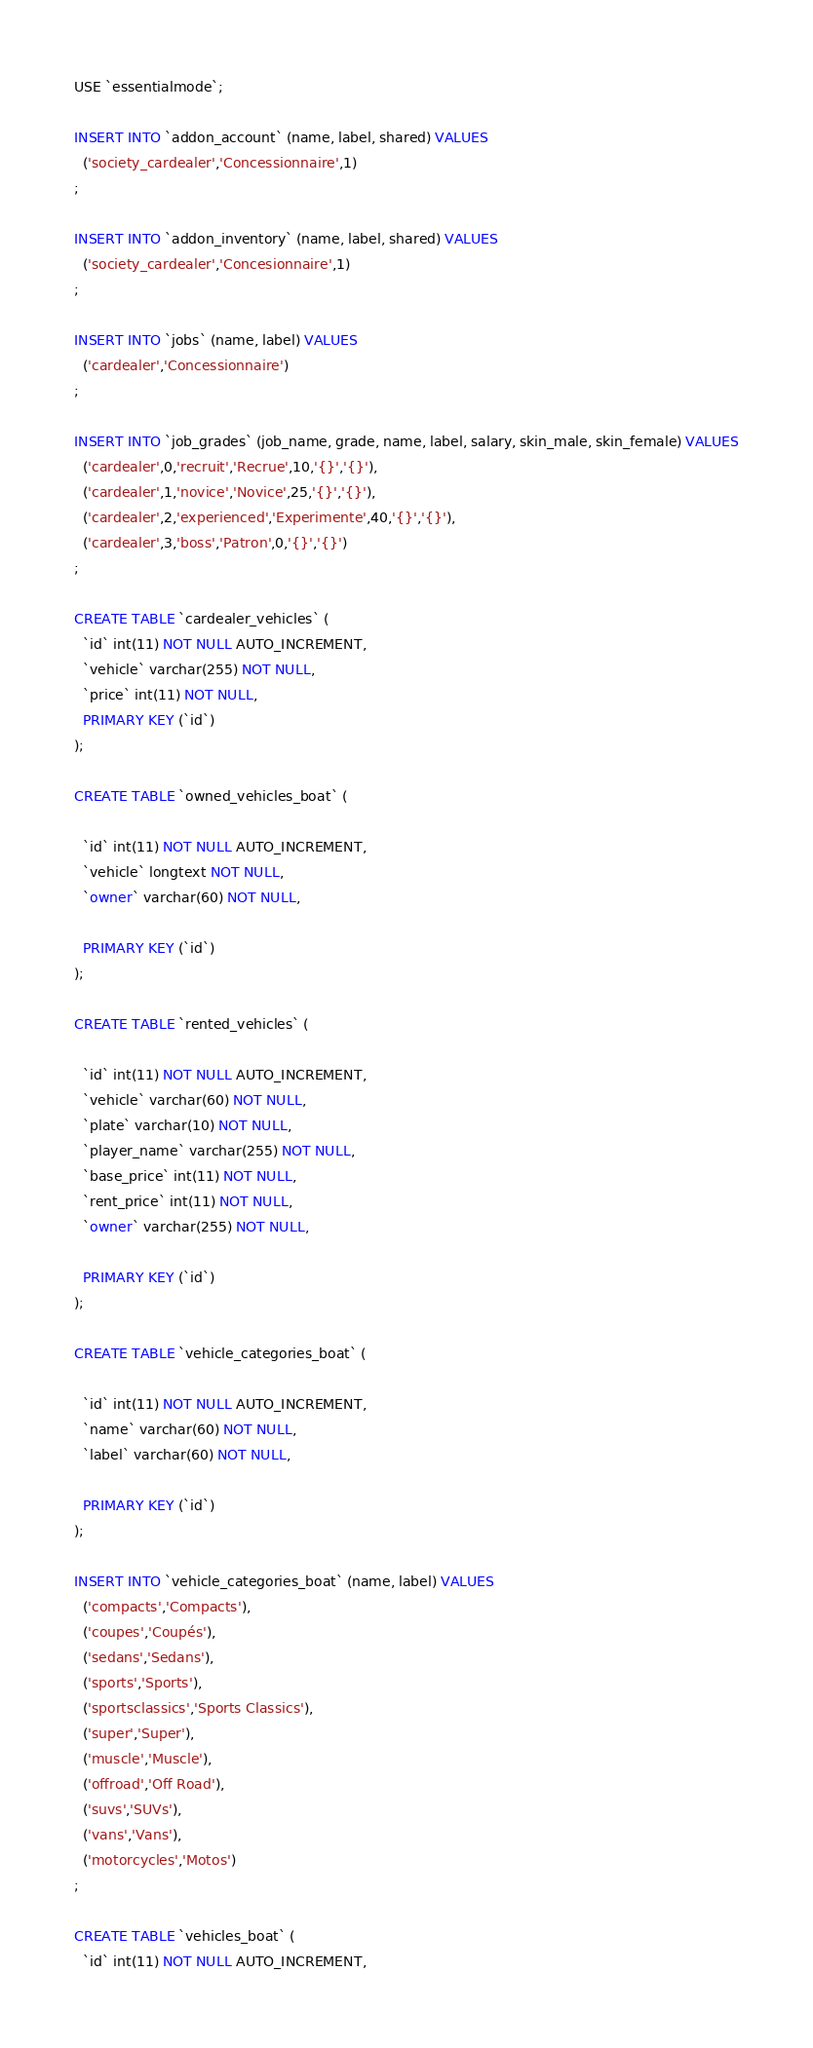<code> <loc_0><loc_0><loc_500><loc_500><_SQL_>USE `essentialmode`;

INSERT INTO `addon_account` (name, label, shared) VALUES
  ('society_cardealer','Concessionnaire',1)
;

INSERT INTO `addon_inventory` (name, label, shared) VALUES
  ('society_cardealer','Concesionnaire',1)
;

INSERT INTO `jobs` (name, label) VALUES
  ('cardealer','Concessionnaire')
;

INSERT INTO `job_grades` (job_name, grade, name, label, salary, skin_male, skin_female) VALUES
  ('cardealer',0,'recruit','Recrue',10,'{}','{}'),
  ('cardealer',1,'novice','Novice',25,'{}','{}'),
  ('cardealer',2,'experienced','Experimente',40,'{}','{}'),
  ('cardealer',3,'boss','Patron',0,'{}','{}')
;

CREATE TABLE `cardealer_vehicles` (
  `id` int(11) NOT NULL AUTO_INCREMENT,
  `vehicle` varchar(255) NOT NULL,
  `price` int(11) NOT NULL,
  PRIMARY KEY (`id`)
);

CREATE TABLE `owned_vehicles_boat` (

  `id` int(11) NOT NULL AUTO_INCREMENT,
  `vehicle` longtext NOT NULL,
  `owner` varchar(60) NOT NULL,

  PRIMARY KEY (`id`)
);

CREATE TABLE `rented_vehicles` (

  `id` int(11) NOT NULL AUTO_INCREMENT,
  `vehicle` varchar(60) NOT NULL,
  `plate` varchar(10) NOT NULL,
  `player_name` varchar(255) NOT NULL,
  `base_price` int(11) NOT NULL,
  `rent_price` int(11) NOT NULL,
  `owner` varchar(255) NOT NULL,

  PRIMARY KEY (`id`)
);

CREATE TABLE `vehicle_categories_boat` (

  `id` int(11) NOT NULL AUTO_INCREMENT,
  `name` varchar(60) NOT NULL,
  `label` varchar(60) NOT NULL,

  PRIMARY KEY (`id`)
);

INSERT INTO `vehicle_categories_boat` (name, label) VALUES
  ('compacts','Compacts'),
  ('coupes','Coupés'),
  ('sedans','Sedans'),
  ('sports','Sports'),
  ('sportsclassics','Sports Classics'),
  ('super','Super'),
  ('muscle','Muscle'),
  ('offroad','Off Road'),
  ('suvs','SUVs'),
  ('vans','Vans'),
  ('motorcycles','Motos')
;

CREATE TABLE `vehicles_boat` (
  `id` int(11) NOT NULL AUTO_INCREMENT,</code> 